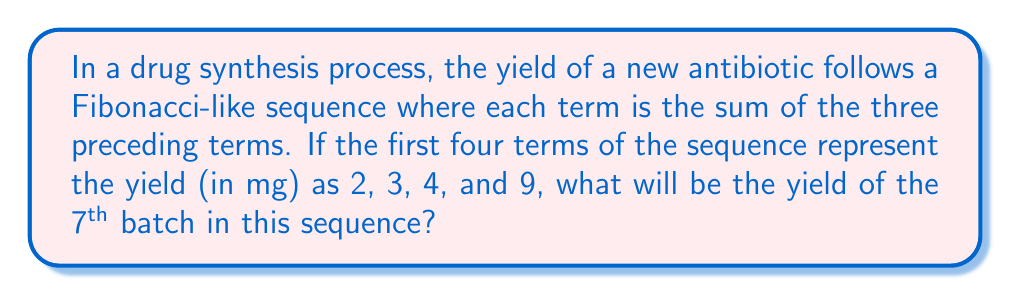Solve this math problem. Let's approach this step-by-step:

1) First, let's write out the given sequence:
   $a_1 = 2$, $a_2 = 3$, $a_3 = 4$, $a_4 = 9$

2) The rule for this Fibonacci-like sequence is:
   $a_n = a_{n-1} + a_{n-2} + a_{n-3}$ for $n \geq 4$

3) Let's calculate the next terms:

   $a_5 = a_4 + a_3 + a_2 = 9 + 4 + 3 = 16$

   $a_6 = a_5 + a_4 + a_3 = 16 + 9 + 4 = 29$

   $a_7 = a_6 + a_5 + a_4 = 29 + 16 + 9 = 54$

4) Therefore, the 7th term in the sequence is 54.

This sequence could model the increasing efficiency of the drug synthesis process as the research team refines their techniques over successive batches.
Answer: 54 mg 